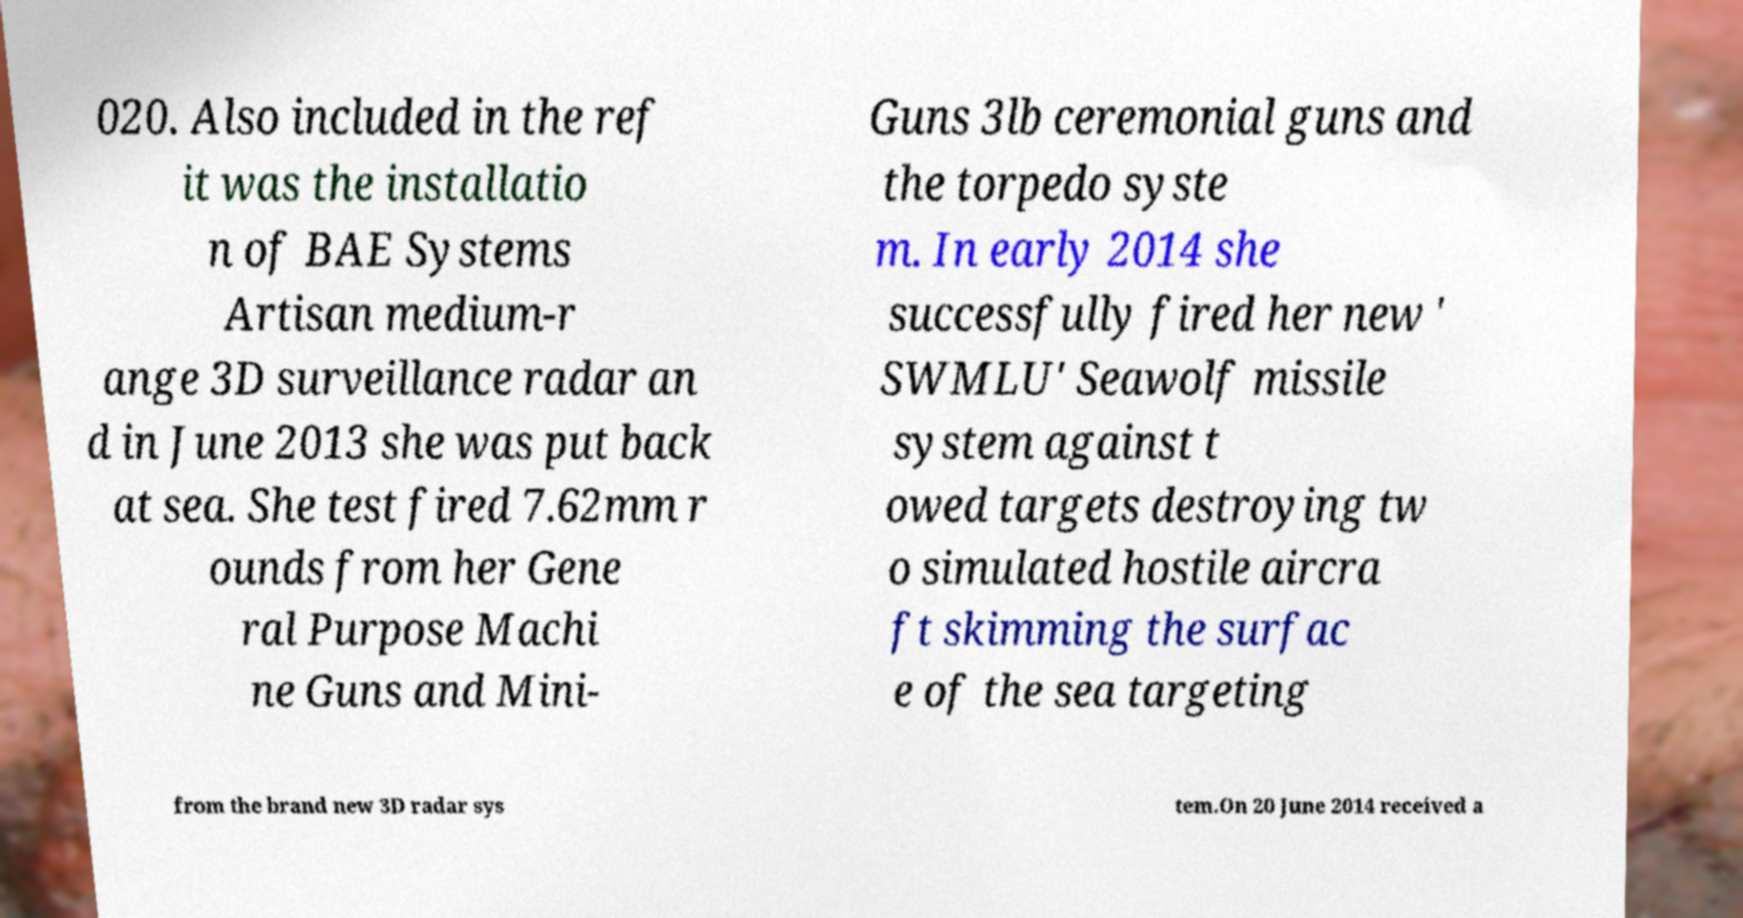Could you assist in decoding the text presented in this image and type it out clearly? 020. Also included in the ref it was the installatio n of BAE Systems Artisan medium-r ange 3D surveillance radar an d in June 2013 she was put back at sea. She test fired 7.62mm r ounds from her Gene ral Purpose Machi ne Guns and Mini- Guns 3lb ceremonial guns and the torpedo syste m. In early 2014 she successfully fired her new ' SWMLU' Seawolf missile system against t owed targets destroying tw o simulated hostile aircra ft skimming the surfac e of the sea targeting from the brand new 3D radar sys tem.On 20 June 2014 received a 